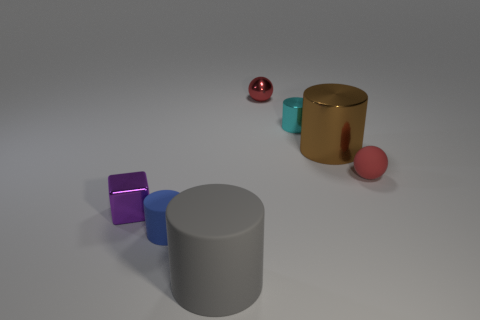Is the color of the large cylinder that is behind the blue cylinder the same as the small metallic cylinder?
Your answer should be compact. No. Do the thing that is to the left of the tiny blue matte object and the thing in front of the tiny blue cylinder have the same size?
Offer a very short reply. No. What is the size of the red sphere that is made of the same material as the small blue object?
Make the answer very short. Small. What number of tiny objects are in front of the cyan shiny thing and to the right of the tiny red shiny ball?
Offer a terse response. 1. What number of things are large cyan matte blocks or metallic things in front of the shiny sphere?
Keep it short and to the point. 3. There is a small object that is to the right of the brown cylinder; what color is it?
Keep it short and to the point. Red. How many things are either metallic objects right of the cube or large objects?
Offer a terse response. 4. There is a block that is the same size as the red metallic sphere; what color is it?
Provide a short and direct response. Purple. Is the number of small red matte balls on the right side of the rubber ball greater than the number of metallic spheres?
Give a very brief answer. No. There is a cylinder that is both to the right of the blue matte object and in front of the small purple shiny object; what is its material?
Ensure brevity in your answer.  Rubber. 